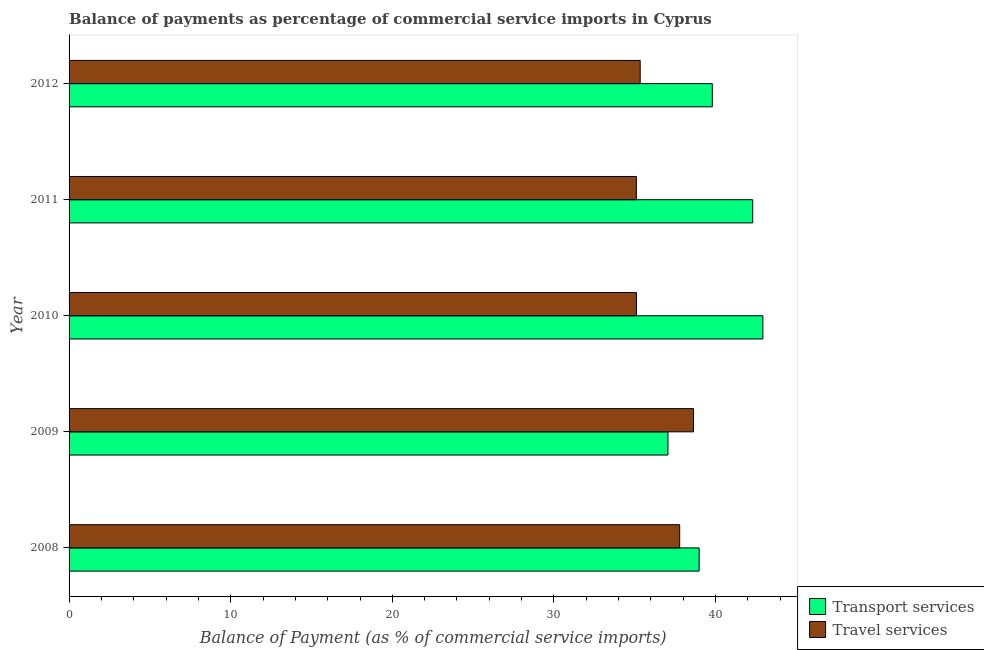How many different coloured bars are there?
Your answer should be very brief. 2. Are the number of bars per tick equal to the number of legend labels?
Your answer should be very brief. Yes. Are the number of bars on each tick of the Y-axis equal?
Ensure brevity in your answer.  Yes. How many bars are there on the 2nd tick from the top?
Make the answer very short. 2. How many bars are there on the 3rd tick from the bottom?
Give a very brief answer. 2. What is the label of the 3rd group of bars from the top?
Give a very brief answer. 2010. In how many cases, is the number of bars for a given year not equal to the number of legend labels?
Your answer should be compact. 0. What is the balance of payments of transport services in 2008?
Offer a very short reply. 38.98. Across all years, what is the maximum balance of payments of travel services?
Give a very brief answer. 38.63. Across all years, what is the minimum balance of payments of travel services?
Keep it short and to the point. 35.1. In which year was the balance of payments of transport services maximum?
Keep it short and to the point. 2010. In which year was the balance of payments of transport services minimum?
Your response must be concise. 2009. What is the total balance of payments of transport services in the graph?
Ensure brevity in your answer.  201.05. What is the difference between the balance of payments of travel services in 2010 and that in 2011?
Provide a succinct answer. 0.01. What is the difference between the balance of payments of transport services in 2009 and the balance of payments of travel services in 2010?
Offer a very short reply. 1.95. What is the average balance of payments of transport services per year?
Keep it short and to the point. 40.21. In the year 2010, what is the difference between the balance of payments of transport services and balance of payments of travel services?
Make the answer very short. 7.82. What is the ratio of the balance of payments of transport services in 2009 to that in 2011?
Your answer should be very brief. 0.88. Is the difference between the balance of payments of travel services in 2009 and 2012 greater than the difference between the balance of payments of transport services in 2009 and 2012?
Your answer should be very brief. Yes. What is the difference between the highest and the second highest balance of payments of transport services?
Your answer should be compact. 0.63. What is the difference between the highest and the lowest balance of payments of transport services?
Your answer should be very brief. 5.87. In how many years, is the balance of payments of transport services greater than the average balance of payments of transport services taken over all years?
Keep it short and to the point. 2. What does the 1st bar from the top in 2011 represents?
Ensure brevity in your answer.  Travel services. What does the 1st bar from the bottom in 2008 represents?
Your answer should be compact. Transport services. How many years are there in the graph?
Offer a terse response. 5. How are the legend labels stacked?
Your response must be concise. Vertical. What is the title of the graph?
Give a very brief answer. Balance of payments as percentage of commercial service imports in Cyprus. What is the label or title of the X-axis?
Ensure brevity in your answer.  Balance of Payment (as % of commercial service imports). What is the label or title of the Y-axis?
Your response must be concise. Year. What is the Balance of Payment (as % of commercial service imports) of Transport services in 2008?
Your answer should be very brief. 38.98. What is the Balance of Payment (as % of commercial service imports) in Travel services in 2008?
Offer a very short reply. 37.78. What is the Balance of Payment (as % of commercial service imports) in Transport services in 2009?
Offer a very short reply. 37.05. What is the Balance of Payment (as % of commercial service imports) in Travel services in 2009?
Your response must be concise. 38.63. What is the Balance of Payment (as % of commercial service imports) of Transport services in 2010?
Your answer should be compact. 42.93. What is the Balance of Payment (as % of commercial service imports) of Travel services in 2010?
Make the answer very short. 35.1. What is the Balance of Payment (as % of commercial service imports) in Transport services in 2011?
Give a very brief answer. 42.3. What is the Balance of Payment (as % of commercial service imports) of Travel services in 2011?
Ensure brevity in your answer.  35.1. What is the Balance of Payment (as % of commercial service imports) in Transport services in 2012?
Make the answer very short. 39.8. What is the Balance of Payment (as % of commercial service imports) of Travel services in 2012?
Ensure brevity in your answer.  35.34. Across all years, what is the maximum Balance of Payment (as % of commercial service imports) in Transport services?
Offer a terse response. 42.93. Across all years, what is the maximum Balance of Payment (as % of commercial service imports) of Travel services?
Provide a succinct answer. 38.63. Across all years, what is the minimum Balance of Payment (as % of commercial service imports) in Transport services?
Offer a very short reply. 37.05. Across all years, what is the minimum Balance of Payment (as % of commercial service imports) in Travel services?
Your answer should be compact. 35.1. What is the total Balance of Payment (as % of commercial service imports) of Transport services in the graph?
Your response must be concise. 201.05. What is the total Balance of Payment (as % of commercial service imports) in Travel services in the graph?
Provide a succinct answer. 181.94. What is the difference between the Balance of Payment (as % of commercial service imports) of Transport services in 2008 and that in 2009?
Keep it short and to the point. 1.93. What is the difference between the Balance of Payment (as % of commercial service imports) in Travel services in 2008 and that in 2009?
Your answer should be very brief. -0.85. What is the difference between the Balance of Payment (as % of commercial service imports) in Transport services in 2008 and that in 2010?
Ensure brevity in your answer.  -3.94. What is the difference between the Balance of Payment (as % of commercial service imports) in Travel services in 2008 and that in 2010?
Your response must be concise. 2.68. What is the difference between the Balance of Payment (as % of commercial service imports) of Transport services in 2008 and that in 2011?
Your answer should be very brief. -3.31. What is the difference between the Balance of Payment (as % of commercial service imports) in Travel services in 2008 and that in 2011?
Your response must be concise. 2.68. What is the difference between the Balance of Payment (as % of commercial service imports) in Transport services in 2008 and that in 2012?
Offer a very short reply. -0.81. What is the difference between the Balance of Payment (as % of commercial service imports) of Travel services in 2008 and that in 2012?
Your response must be concise. 2.44. What is the difference between the Balance of Payment (as % of commercial service imports) in Transport services in 2009 and that in 2010?
Your response must be concise. -5.87. What is the difference between the Balance of Payment (as % of commercial service imports) in Travel services in 2009 and that in 2010?
Offer a terse response. 3.53. What is the difference between the Balance of Payment (as % of commercial service imports) of Transport services in 2009 and that in 2011?
Offer a terse response. -5.24. What is the difference between the Balance of Payment (as % of commercial service imports) of Travel services in 2009 and that in 2011?
Your answer should be compact. 3.53. What is the difference between the Balance of Payment (as % of commercial service imports) of Transport services in 2009 and that in 2012?
Offer a very short reply. -2.75. What is the difference between the Balance of Payment (as % of commercial service imports) of Travel services in 2009 and that in 2012?
Your answer should be very brief. 3.29. What is the difference between the Balance of Payment (as % of commercial service imports) in Transport services in 2010 and that in 2011?
Ensure brevity in your answer.  0.63. What is the difference between the Balance of Payment (as % of commercial service imports) in Travel services in 2010 and that in 2011?
Keep it short and to the point. 0. What is the difference between the Balance of Payment (as % of commercial service imports) of Transport services in 2010 and that in 2012?
Ensure brevity in your answer.  3.13. What is the difference between the Balance of Payment (as % of commercial service imports) of Travel services in 2010 and that in 2012?
Keep it short and to the point. -0.23. What is the difference between the Balance of Payment (as % of commercial service imports) of Transport services in 2011 and that in 2012?
Provide a succinct answer. 2.5. What is the difference between the Balance of Payment (as % of commercial service imports) of Travel services in 2011 and that in 2012?
Ensure brevity in your answer.  -0.24. What is the difference between the Balance of Payment (as % of commercial service imports) of Transport services in 2008 and the Balance of Payment (as % of commercial service imports) of Travel services in 2009?
Your response must be concise. 0.35. What is the difference between the Balance of Payment (as % of commercial service imports) of Transport services in 2008 and the Balance of Payment (as % of commercial service imports) of Travel services in 2010?
Make the answer very short. 3.88. What is the difference between the Balance of Payment (as % of commercial service imports) of Transport services in 2008 and the Balance of Payment (as % of commercial service imports) of Travel services in 2011?
Give a very brief answer. 3.88. What is the difference between the Balance of Payment (as % of commercial service imports) of Transport services in 2008 and the Balance of Payment (as % of commercial service imports) of Travel services in 2012?
Your answer should be very brief. 3.65. What is the difference between the Balance of Payment (as % of commercial service imports) in Transport services in 2009 and the Balance of Payment (as % of commercial service imports) in Travel services in 2010?
Ensure brevity in your answer.  1.95. What is the difference between the Balance of Payment (as % of commercial service imports) in Transport services in 2009 and the Balance of Payment (as % of commercial service imports) in Travel services in 2011?
Your response must be concise. 1.95. What is the difference between the Balance of Payment (as % of commercial service imports) of Transport services in 2009 and the Balance of Payment (as % of commercial service imports) of Travel services in 2012?
Keep it short and to the point. 1.72. What is the difference between the Balance of Payment (as % of commercial service imports) of Transport services in 2010 and the Balance of Payment (as % of commercial service imports) of Travel services in 2011?
Your answer should be very brief. 7.83. What is the difference between the Balance of Payment (as % of commercial service imports) of Transport services in 2010 and the Balance of Payment (as % of commercial service imports) of Travel services in 2012?
Your answer should be very brief. 7.59. What is the difference between the Balance of Payment (as % of commercial service imports) of Transport services in 2011 and the Balance of Payment (as % of commercial service imports) of Travel services in 2012?
Give a very brief answer. 6.96. What is the average Balance of Payment (as % of commercial service imports) of Transport services per year?
Your response must be concise. 40.21. What is the average Balance of Payment (as % of commercial service imports) of Travel services per year?
Offer a very short reply. 36.39. In the year 2008, what is the difference between the Balance of Payment (as % of commercial service imports) in Transport services and Balance of Payment (as % of commercial service imports) in Travel services?
Offer a very short reply. 1.2. In the year 2009, what is the difference between the Balance of Payment (as % of commercial service imports) of Transport services and Balance of Payment (as % of commercial service imports) of Travel services?
Make the answer very short. -1.58. In the year 2010, what is the difference between the Balance of Payment (as % of commercial service imports) of Transport services and Balance of Payment (as % of commercial service imports) of Travel services?
Your answer should be very brief. 7.82. In the year 2011, what is the difference between the Balance of Payment (as % of commercial service imports) in Transport services and Balance of Payment (as % of commercial service imports) in Travel services?
Give a very brief answer. 7.2. In the year 2012, what is the difference between the Balance of Payment (as % of commercial service imports) in Transport services and Balance of Payment (as % of commercial service imports) in Travel services?
Offer a very short reply. 4.46. What is the ratio of the Balance of Payment (as % of commercial service imports) in Transport services in 2008 to that in 2009?
Provide a short and direct response. 1.05. What is the ratio of the Balance of Payment (as % of commercial service imports) of Travel services in 2008 to that in 2009?
Make the answer very short. 0.98. What is the ratio of the Balance of Payment (as % of commercial service imports) in Transport services in 2008 to that in 2010?
Your answer should be compact. 0.91. What is the ratio of the Balance of Payment (as % of commercial service imports) in Travel services in 2008 to that in 2010?
Your answer should be compact. 1.08. What is the ratio of the Balance of Payment (as % of commercial service imports) of Transport services in 2008 to that in 2011?
Ensure brevity in your answer.  0.92. What is the ratio of the Balance of Payment (as % of commercial service imports) in Travel services in 2008 to that in 2011?
Keep it short and to the point. 1.08. What is the ratio of the Balance of Payment (as % of commercial service imports) of Transport services in 2008 to that in 2012?
Provide a succinct answer. 0.98. What is the ratio of the Balance of Payment (as % of commercial service imports) of Travel services in 2008 to that in 2012?
Give a very brief answer. 1.07. What is the ratio of the Balance of Payment (as % of commercial service imports) in Transport services in 2009 to that in 2010?
Your response must be concise. 0.86. What is the ratio of the Balance of Payment (as % of commercial service imports) in Travel services in 2009 to that in 2010?
Your answer should be compact. 1.1. What is the ratio of the Balance of Payment (as % of commercial service imports) of Transport services in 2009 to that in 2011?
Your answer should be very brief. 0.88. What is the ratio of the Balance of Payment (as % of commercial service imports) of Travel services in 2009 to that in 2011?
Ensure brevity in your answer.  1.1. What is the ratio of the Balance of Payment (as % of commercial service imports) in Transport services in 2009 to that in 2012?
Your answer should be very brief. 0.93. What is the ratio of the Balance of Payment (as % of commercial service imports) of Travel services in 2009 to that in 2012?
Provide a succinct answer. 1.09. What is the ratio of the Balance of Payment (as % of commercial service imports) in Transport services in 2010 to that in 2011?
Offer a terse response. 1.01. What is the ratio of the Balance of Payment (as % of commercial service imports) of Transport services in 2010 to that in 2012?
Your response must be concise. 1.08. What is the ratio of the Balance of Payment (as % of commercial service imports) in Travel services in 2010 to that in 2012?
Provide a short and direct response. 0.99. What is the ratio of the Balance of Payment (as % of commercial service imports) in Transport services in 2011 to that in 2012?
Provide a succinct answer. 1.06. What is the ratio of the Balance of Payment (as % of commercial service imports) in Travel services in 2011 to that in 2012?
Your response must be concise. 0.99. What is the difference between the highest and the second highest Balance of Payment (as % of commercial service imports) in Transport services?
Provide a succinct answer. 0.63. What is the difference between the highest and the second highest Balance of Payment (as % of commercial service imports) in Travel services?
Provide a short and direct response. 0.85. What is the difference between the highest and the lowest Balance of Payment (as % of commercial service imports) in Transport services?
Your answer should be compact. 5.87. What is the difference between the highest and the lowest Balance of Payment (as % of commercial service imports) of Travel services?
Make the answer very short. 3.53. 